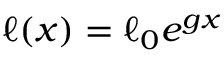<formula> <loc_0><loc_0><loc_500><loc_500>\ell ( x ) = \ell _ { 0 } e ^ { g x }</formula> 